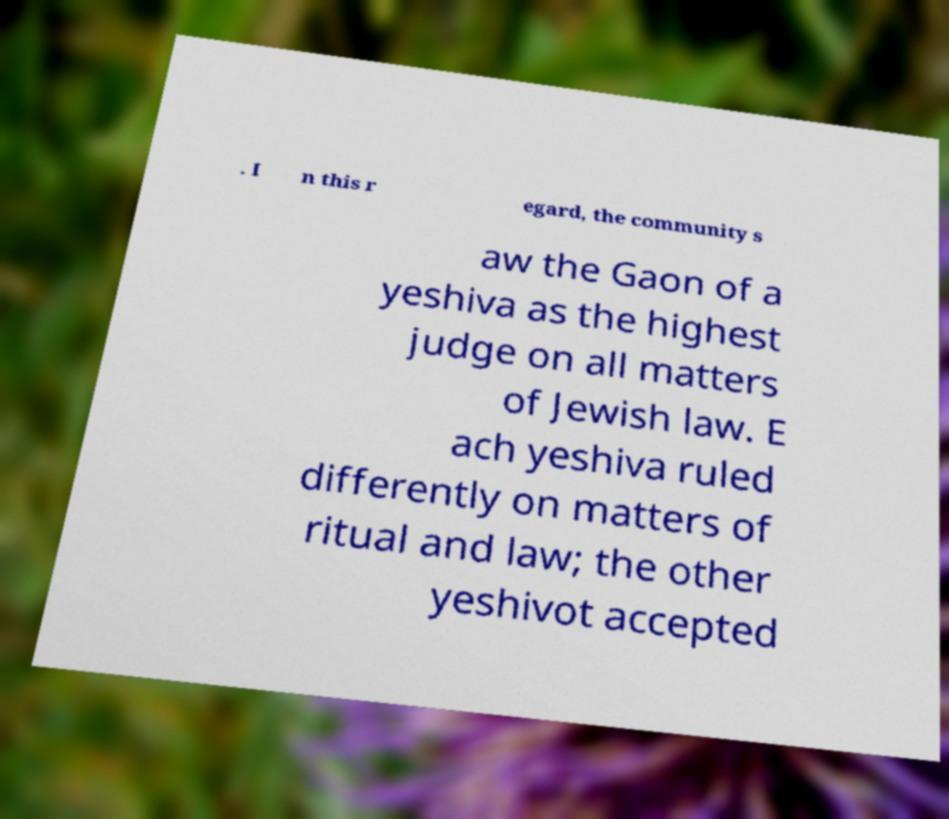Can you read and provide the text displayed in the image?This photo seems to have some interesting text. Can you extract and type it out for me? . I n this r egard, the community s aw the Gaon of a yeshiva as the highest judge on all matters of Jewish law. E ach yeshiva ruled differently on matters of ritual and law; the other yeshivot accepted 